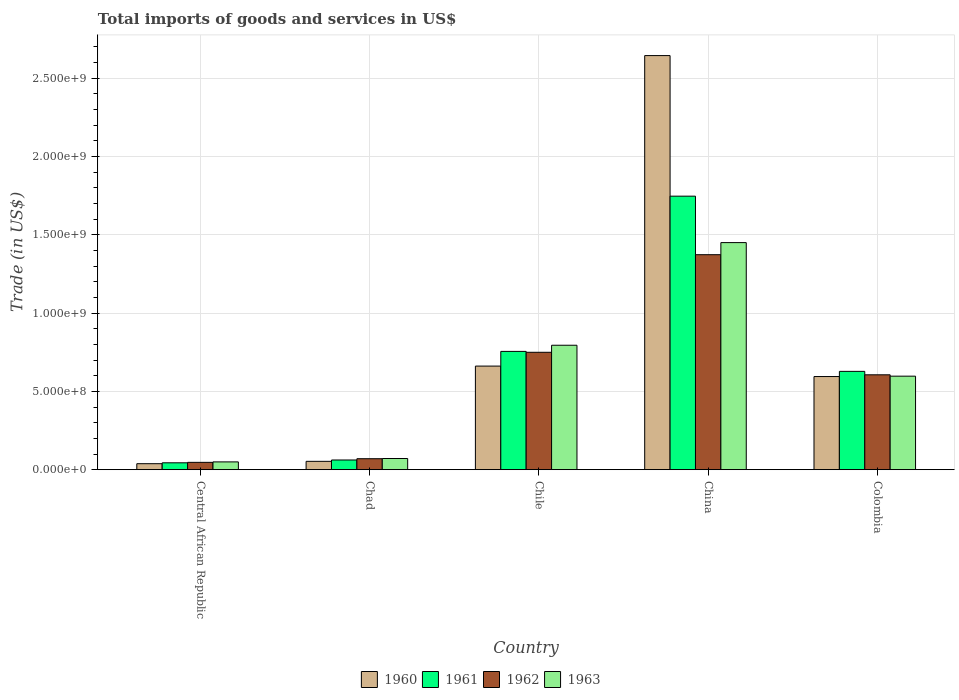How many different coloured bars are there?
Provide a succinct answer. 4. How many bars are there on the 3rd tick from the left?
Keep it short and to the point. 4. What is the label of the 5th group of bars from the left?
Your answer should be very brief. Colombia. What is the total imports of goods and services in 1960 in Central African Republic?
Provide a succinct answer. 3.83e+07. Across all countries, what is the maximum total imports of goods and services in 1963?
Ensure brevity in your answer.  1.45e+09. Across all countries, what is the minimum total imports of goods and services in 1960?
Keep it short and to the point. 3.83e+07. In which country was the total imports of goods and services in 1960 maximum?
Your response must be concise. China. In which country was the total imports of goods and services in 1961 minimum?
Your answer should be very brief. Central African Republic. What is the total total imports of goods and services in 1962 in the graph?
Ensure brevity in your answer.  2.85e+09. What is the difference between the total imports of goods and services in 1963 in China and that in Colombia?
Your response must be concise. 8.53e+08. What is the difference between the total imports of goods and services in 1963 in Chile and the total imports of goods and services in 1960 in Colombia?
Offer a very short reply. 2.00e+08. What is the average total imports of goods and services in 1962 per country?
Your answer should be compact. 5.69e+08. What is the difference between the total imports of goods and services of/in 1961 and total imports of goods and services of/in 1960 in Chad?
Offer a terse response. 8.55e+06. What is the ratio of the total imports of goods and services in 1963 in Central African Republic to that in Colombia?
Provide a succinct answer. 0.08. Is the total imports of goods and services in 1960 in Chile less than that in China?
Your response must be concise. Yes. What is the difference between the highest and the second highest total imports of goods and services in 1962?
Give a very brief answer. -1.44e+08. What is the difference between the highest and the lowest total imports of goods and services in 1960?
Your answer should be very brief. 2.61e+09. In how many countries, is the total imports of goods and services in 1960 greater than the average total imports of goods and services in 1960 taken over all countries?
Provide a short and direct response. 1. Is the sum of the total imports of goods and services in 1963 in Central African Republic and Chile greater than the maximum total imports of goods and services in 1961 across all countries?
Your answer should be very brief. No. What does the 2nd bar from the right in China represents?
Offer a terse response. 1962. How many bars are there?
Give a very brief answer. 20. How many legend labels are there?
Provide a short and direct response. 4. What is the title of the graph?
Make the answer very short. Total imports of goods and services in US$. What is the label or title of the Y-axis?
Offer a very short reply. Trade (in US$). What is the Trade (in US$) of 1960 in Central African Republic?
Offer a terse response. 3.83e+07. What is the Trade (in US$) in 1961 in Central African Republic?
Provide a short and direct response. 4.40e+07. What is the Trade (in US$) in 1962 in Central African Republic?
Your answer should be compact. 4.69e+07. What is the Trade (in US$) in 1963 in Central African Republic?
Your response must be concise. 4.98e+07. What is the Trade (in US$) in 1960 in Chad?
Give a very brief answer. 5.34e+07. What is the Trade (in US$) in 1961 in Chad?
Ensure brevity in your answer.  6.20e+07. What is the Trade (in US$) in 1962 in Chad?
Make the answer very short. 7.02e+07. What is the Trade (in US$) of 1963 in Chad?
Your answer should be compact. 7.14e+07. What is the Trade (in US$) of 1960 in Chile?
Your answer should be compact. 6.62e+08. What is the Trade (in US$) of 1961 in Chile?
Give a very brief answer. 7.55e+08. What is the Trade (in US$) in 1962 in Chile?
Your response must be concise. 7.50e+08. What is the Trade (in US$) of 1963 in Chile?
Your answer should be compact. 7.95e+08. What is the Trade (in US$) in 1960 in China?
Provide a short and direct response. 2.64e+09. What is the Trade (in US$) of 1961 in China?
Offer a very short reply. 1.75e+09. What is the Trade (in US$) in 1962 in China?
Your response must be concise. 1.37e+09. What is the Trade (in US$) of 1963 in China?
Provide a short and direct response. 1.45e+09. What is the Trade (in US$) of 1960 in Colombia?
Offer a terse response. 5.95e+08. What is the Trade (in US$) in 1961 in Colombia?
Provide a short and direct response. 6.28e+08. What is the Trade (in US$) of 1962 in Colombia?
Give a very brief answer. 6.06e+08. What is the Trade (in US$) in 1963 in Colombia?
Keep it short and to the point. 5.97e+08. Across all countries, what is the maximum Trade (in US$) in 1960?
Offer a terse response. 2.64e+09. Across all countries, what is the maximum Trade (in US$) of 1961?
Ensure brevity in your answer.  1.75e+09. Across all countries, what is the maximum Trade (in US$) in 1962?
Offer a terse response. 1.37e+09. Across all countries, what is the maximum Trade (in US$) of 1963?
Provide a succinct answer. 1.45e+09. Across all countries, what is the minimum Trade (in US$) of 1960?
Your answer should be very brief. 3.83e+07. Across all countries, what is the minimum Trade (in US$) in 1961?
Offer a very short reply. 4.40e+07. Across all countries, what is the minimum Trade (in US$) of 1962?
Your answer should be very brief. 4.69e+07. Across all countries, what is the minimum Trade (in US$) in 1963?
Offer a very short reply. 4.98e+07. What is the total Trade (in US$) of 1960 in the graph?
Your answer should be very brief. 3.99e+09. What is the total Trade (in US$) of 1961 in the graph?
Make the answer very short. 3.24e+09. What is the total Trade (in US$) in 1962 in the graph?
Provide a short and direct response. 2.85e+09. What is the total Trade (in US$) in 1963 in the graph?
Your answer should be compact. 2.96e+09. What is the difference between the Trade (in US$) of 1960 in Central African Republic and that in Chad?
Your response must be concise. -1.51e+07. What is the difference between the Trade (in US$) in 1961 in Central African Republic and that in Chad?
Give a very brief answer. -1.79e+07. What is the difference between the Trade (in US$) of 1962 in Central African Republic and that in Chad?
Provide a succinct answer. -2.33e+07. What is the difference between the Trade (in US$) in 1963 in Central African Republic and that in Chad?
Ensure brevity in your answer.  -2.16e+07. What is the difference between the Trade (in US$) in 1960 in Central African Republic and that in Chile?
Offer a very short reply. -6.23e+08. What is the difference between the Trade (in US$) of 1961 in Central African Republic and that in Chile?
Your answer should be compact. -7.11e+08. What is the difference between the Trade (in US$) in 1962 in Central African Republic and that in Chile?
Your answer should be compact. -7.03e+08. What is the difference between the Trade (in US$) of 1963 in Central African Republic and that in Chile?
Make the answer very short. -7.45e+08. What is the difference between the Trade (in US$) in 1960 in Central African Republic and that in China?
Give a very brief answer. -2.61e+09. What is the difference between the Trade (in US$) in 1961 in Central African Republic and that in China?
Offer a very short reply. -1.70e+09. What is the difference between the Trade (in US$) of 1962 in Central African Republic and that in China?
Make the answer very short. -1.33e+09. What is the difference between the Trade (in US$) of 1963 in Central African Republic and that in China?
Ensure brevity in your answer.  -1.40e+09. What is the difference between the Trade (in US$) in 1960 in Central African Republic and that in Colombia?
Offer a very short reply. -5.57e+08. What is the difference between the Trade (in US$) in 1961 in Central African Republic and that in Colombia?
Offer a very short reply. -5.84e+08. What is the difference between the Trade (in US$) of 1962 in Central African Republic and that in Colombia?
Offer a very short reply. -5.59e+08. What is the difference between the Trade (in US$) in 1963 in Central African Republic and that in Colombia?
Make the answer very short. -5.47e+08. What is the difference between the Trade (in US$) in 1960 in Chad and that in Chile?
Give a very brief answer. -6.08e+08. What is the difference between the Trade (in US$) in 1961 in Chad and that in Chile?
Provide a succinct answer. -6.93e+08. What is the difference between the Trade (in US$) of 1962 in Chad and that in Chile?
Provide a succinct answer. -6.80e+08. What is the difference between the Trade (in US$) of 1963 in Chad and that in Chile?
Your answer should be compact. -7.23e+08. What is the difference between the Trade (in US$) in 1960 in Chad and that in China?
Offer a terse response. -2.59e+09. What is the difference between the Trade (in US$) in 1961 in Chad and that in China?
Provide a short and direct response. -1.68e+09. What is the difference between the Trade (in US$) in 1962 in Chad and that in China?
Your response must be concise. -1.30e+09. What is the difference between the Trade (in US$) of 1963 in Chad and that in China?
Offer a very short reply. -1.38e+09. What is the difference between the Trade (in US$) in 1960 in Chad and that in Colombia?
Your response must be concise. -5.41e+08. What is the difference between the Trade (in US$) in 1961 in Chad and that in Colombia?
Make the answer very short. -5.66e+08. What is the difference between the Trade (in US$) in 1962 in Chad and that in Colombia?
Ensure brevity in your answer.  -5.36e+08. What is the difference between the Trade (in US$) in 1963 in Chad and that in Colombia?
Keep it short and to the point. -5.26e+08. What is the difference between the Trade (in US$) of 1960 in Chile and that in China?
Provide a succinct answer. -1.98e+09. What is the difference between the Trade (in US$) of 1961 in Chile and that in China?
Your answer should be very brief. -9.91e+08. What is the difference between the Trade (in US$) of 1962 in Chile and that in China?
Your response must be concise. -6.23e+08. What is the difference between the Trade (in US$) in 1963 in Chile and that in China?
Provide a succinct answer. -6.55e+08. What is the difference between the Trade (in US$) of 1960 in Chile and that in Colombia?
Offer a terse response. 6.68e+07. What is the difference between the Trade (in US$) of 1961 in Chile and that in Colombia?
Offer a very short reply. 1.28e+08. What is the difference between the Trade (in US$) of 1962 in Chile and that in Colombia?
Offer a terse response. 1.44e+08. What is the difference between the Trade (in US$) in 1963 in Chile and that in Colombia?
Your response must be concise. 1.97e+08. What is the difference between the Trade (in US$) in 1960 in China and that in Colombia?
Provide a succinct answer. 2.05e+09. What is the difference between the Trade (in US$) in 1961 in China and that in Colombia?
Provide a short and direct response. 1.12e+09. What is the difference between the Trade (in US$) of 1962 in China and that in Colombia?
Make the answer very short. 7.67e+08. What is the difference between the Trade (in US$) in 1963 in China and that in Colombia?
Ensure brevity in your answer.  8.53e+08. What is the difference between the Trade (in US$) in 1960 in Central African Republic and the Trade (in US$) in 1961 in Chad?
Your answer should be very brief. -2.36e+07. What is the difference between the Trade (in US$) in 1960 in Central African Republic and the Trade (in US$) in 1962 in Chad?
Give a very brief answer. -3.19e+07. What is the difference between the Trade (in US$) in 1960 in Central African Republic and the Trade (in US$) in 1963 in Chad?
Make the answer very short. -3.31e+07. What is the difference between the Trade (in US$) of 1961 in Central African Republic and the Trade (in US$) of 1962 in Chad?
Your response must be concise. -2.62e+07. What is the difference between the Trade (in US$) in 1961 in Central African Republic and the Trade (in US$) in 1963 in Chad?
Provide a short and direct response. -2.74e+07. What is the difference between the Trade (in US$) in 1962 in Central African Republic and the Trade (in US$) in 1963 in Chad?
Your answer should be compact. -2.45e+07. What is the difference between the Trade (in US$) in 1960 in Central African Republic and the Trade (in US$) in 1961 in Chile?
Make the answer very short. -7.17e+08. What is the difference between the Trade (in US$) in 1960 in Central African Republic and the Trade (in US$) in 1962 in Chile?
Give a very brief answer. -7.11e+08. What is the difference between the Trade (in US$) in 1960 in Central African Republic and the Trade (in US$) in 1963 in Chile?
Your answer should be very brief. -7.56e+08. What is the difference between the Trade (in US$) in 1961 in Central African Republic and the Trade (in US$) in 1962 in Chile?
Provide a succinct answer. -7.06e+08. What is the difference between the Trade (in US$) of 1961 in Central African Republic and the Trade (in US$) of 1963 in Chile?
Offer a terse response. -7.51e+08. What is the difference between the Trade (in US$) in 1962 in Central African Republic and the Trade (in US$) in 1963 in Chile?
Your answer should be very brief. -7.48e+08. What is the difference between the Trade (in US$) in 1960 in Central African Republic and the Trade (in US$) in 1961 in China?
Your answer should be compact. -1.71e+09. What is the difference between the Trade (in US$) in 1960 in Central African Republic and the Trade (in US$) in 1962 in China?
Make the answer very short. -1.33e+09. What is the difference between the Trade (in US$) in 1960 in Central African Republic and the Trade (in US$) in 1963 in China?
Ensure brevity in your answer.  -1.41e+09. What is the difference between the Trade (in US$) of 1961 in Central African Republic and the Trade (in US$) of 1962 in China?
Keep it short and to the point. -1.33e+09. What is the difference between the Trade (in US$) in 1961 in Central African Republic and the Trade (in US$) in 1963 in China?
Provide a succinct answer. -1.41e+09. What is the difference between the Trade (in US$) of 1962 in Central African Republic and the Trade (in US$) of 1963 in China?
Offer a terse response. -1.40e+09. What is the difference between the Trade (in US$) in 1960 in Central African Republic and the Trade (in US$) in 1961 in Colombia?
Make the answer very short. -5.90e+08. What is the difference between the Trade (in US$) in 1960 in Central African Republic and the Trade (in US$) in 1962 in Colombia?
Your response must be concise. -5.68e+08. What is the difference between the Trade (in US$) in 1960 in Central African Republic and the Trade (in US$) in 1963 in Colombia?
Offer a terse response. -5.59e+08. What is the difference between the Trade (in US$) in 1961 in Central African Republic and the Trade (in US$) in 1962 in Colombia?
Your answer should be very brief. -5.62e+08. What is the difference between the Trade (in US$) of 1961 in Central African Republic and the Trade (in US$) of 1963 in Colombia?
Provide a succinct answer. -5.53e+08. What is the difference between the Trade (in US$) in 1962 in Central African Republic and the Trade (in US$) in 1963 in Colombia?
Give a very brief answer. -5.50e+08. What is the difference between the Trade (in US$) in 1960 in Chad and the Trade (in US$) in 1961 in Chile?
Keep it short and to the point. -7.02e+08. What is the difference between the Trade (in US$) of 1960 in Chad and the Trade (in US$) of 1962 in Chile?
Make the answer very short. -6.96e+08. What is the difference between the Trade (in US$) in 1960 in Chad and the Trade (in US$) in 1963 in Chile?
Ensure brevity in your answer.  -7.41e+08. What is the difference between the Trade (in US$) in 1961 in Chad and the Trade (in US$) in 1962 in Chile?
Offer a very short reply. -6.88e+08. What is the difference between the Trade (in US$) in 1961 in Chad and the Trade (in US$) in 1963 in Chile?
Your answer should be very brief. -7.33e+08. What is the difference between the Trade (in US$) of 1962 in Chad and the Trade (in US$) of 1963 in Chile?
Provide a short and direct response. -7.25e+08. What is the difference between the Trade (in US$) in 1960 in Chad and the Trade (in US$) in 1961 in China?
Offer a very short reply. -1.69e+09. What is the difference between the Trade (in US$) in 1960 in Chad and the Trade (in US$) in 1962 in China?
Keep it short and to the point. -1.32e+09. What is the difference between the Trade (in US$) in 1960 in Chad and the Trade (in US$) in 1963 in China?
Your answer should be compact. -1.40e+09. What is the difference between the Trade (in US$) of 1961 in Chad and the Trade (in US$) of 1962 in China?
Make the answer very short. -1.31e+09. What is the difference between the Trade (in US$) in 1961 in Chad and the Trade (in US$) in 1963 in China?
Keep it short and to the point. -1.39e+09. What is the difference between the Trade (in US$) of 1962 in Chad and the Trade (in US$) of 1963 in China?
Ensure brevity in your answer.  -1.38e+09. What is the difference between the Trade (in US$) in 1960 in Chad and the Trade (in US$) in 1961 in Colombia?
Provide a succinct answer. -5.75e+08. What is the difference between the Trade (in US$) in 1960 in Chad and the Trade (in US$) in 1962 in Colombia?
Provide a short and direct response. -5.53e+08. What is the difference between the Trade (in US$) of 1960 in Chad and the Trade (in US$) of 1963 in Colombia?
Provide a succinct answer. -5.44e+08. What is the difference between the Trade (in US$) in 1961 in Chad and the Trade (in US$) in 1962 in Colombia?
Provide a succinct answer. -5.44e+08. What is the difference between the Trade (in US$) of 1961 in Chad and the Trade (in US$) of 1963 in Colombia?
Give a very brief answer. -5.35e+08. What is the difference between the Trade (in US$) of 1962 in Chad and the Trade (in US$) of 1963 in Colombia?
Ensure brevity in your answer.  -5.27e+08. What is the difference between the Trade (in US$) of 1960 in Chile and the Trade (in US$) of 1961 in China?
Your answer should be very brief. -1.09e+09. What is the difference between the Trade (in US$) of 1960 in Chile and the Trade (in US$) of 1962 in China?
Offer a very short reply. -7.11e+08. What is the difference between the Trade (in US$) of 1960 in Chile and the Trade (in US$) of 1963 in China?
Provide a succinct answer. -7.88e+08. What is the difference between the Trade (in US$) of 1961 in Chile and the Trade (in US$) of 1962 in China?
Ensure brevity in your answer.  -6.18e+08. What is the difference between the Trade (in US$) of 1961 in Chile and the Trade (in US$) of 1963 in China?
Ensure brevity in your answer.  -6.95e+08. What is the difference between the Trade (in US$) of 1962 in Chile and the Trade (in US$) of 1963 in China?
Ensure brevity in your answer.  -7.00e+08. What is the difference between the Trade (in US$) in 1960 in Chile and the Trade (in US$) in 1961 in Colombia?
Make the answer very short. 3.37e+07. What is the difference between the Trade (in US$) of 1960 in Chile and the Trade (in US$) of 1962 in Colombia?
Your response must be concise. 5.57e+07. What is the difference between the Trade (in US$) in 1960 in Chile and the Trade (in US$) in 1963 in Colombia?
Provide a succinct answer. 6.44e+07. What is the difference between the Trade (in US$) of 1961 in Chile and the Trade (in US$) of 1962 in Colombia?
Your answer should be very brief. 1.50e+08. What is the difference between the Trade (in US$) of 1961 in Chile and the Trade (in US$) of 1963 in Colombia?
Provide a succinct answer. 1.58e+08. What is the difference between the Trade (in US$) in 1962 in Chile and the Trade (in US$) in 1963 in Colombia?
Your response must be concise. 1.52e+08. What is the difference between the Trade (in US$) of 1960 in China and the Trade (in US$) of 1961 in Colombia?
Your answer should be very brief. 2.02e+09. What is the difference between the Trade (in US$) of 1960 in China and the Trade (in US$) of 1962 in Colombia?
Your answer should be compact. 2.04e+09. What is the difference between the Trade (in US$) in 1960 in China and the Trade (in US$) in 1963 in Colombia?
Your answer should be very brief. 2.05e+09. What is the difference between the Trade (in US$) in 1961 in China and the Trade (in US$) in 1962 in Colombia?
Make the answer very short. 1.14e+09. What is the difference between the Trade (in US$) of 1961 in China and the Trade (in US$) of 1963 in Colombia?
Provide a short and direct response. 1.15e+09. What is the difference between the Trade (in US$) of 1962 in China and the Trade (in US$) of 1963 in Colombia?
Offer a very short reply. 7.76e+08. What is the average Trade (in US$) of 1960 per country?
Provide a short and direct response. 7.99e+08. What is the average Trade (in US$) of 1961 per country?
Offer a terse response. 6.47e+08. What is the average Trade (in US$) of 1962 per country?
Ensure brevity in your answer.  5.69e+08. What is the average Trade (in US$) of 1963 per country?
Give a very brief answer. 5.93e+08. What is the difference between the Trade (in US$) in 1960 and Trade (in US$) in 1961 in Central African Republic?
Your answer should be very brief. -5.70e+06. What is the difference between the Trade (in US$) in 1960 and Trade (in US$) in 1962 in Central African Republic?
Your response must be concise. -8.60e+06. What is the difference between the Trade (in US$) of 1960 and Trade (in US$) of 1963 in Central African Republic?
Keep it short and to the point. -1.15e+07. What is the difference between the Trade (in US$) in 1961 and Trade (in US$) in 1962 in Central African Republic?
Offer a very short reply. -2.90e+06. What is the difference between the Trade (in US$) of 1961 and Trade (in US$) of 1963 in Central African Republic?
Make the answer very short. -5.76e+06. What is the difference between the Trade (in US$) in 1962 and Trade (in US$) in 1963 in Central African Republic?
Ensure brevity in your answer.  -2.86e+06. What is the difference between the Trade (in US$) in 1960 and Trade (in US$) in 1961 in Chad?
Provide a short and direct response. -8.55e+06. What is the difference between the Trade (in US$) in 1960 and Trade (in US$) in 1962 in Chad?
Provide a short and direct response. -1.68e+07. What is the difference between the Trade (in US$) in 1960 and Trade (in US$) in 1963 in Chad?
Provide a succinct answer. -1.80e+07. What is the difference between the Trade (in US$) of 1961 and Trade (in US$) of 1962 in Chad?
Provide a succinct answer. -8.23e+06. What is the difference between the Trade (in US$) in 1961 and Trade (in US$) in 1963 in Chad?
Your answer should be compact. -9.45e+06. What is the difference between the Trade (in US$) of 1962 and Trade (in US$) of 1963 in Chad?
Ensure brevity in your answer.  -1.22e+06. What is the difference between the Trade (in US$) of 1960 and Trade (in US$) of 1961 in Chile?
Offer a very short reply. -9.38e+07. What is the difference between the Trade (in US$) of 1960 and Trade (in US$) of 1962 in Chile?
Keep it short and to the point. -8.81e+07. What is the difference between the Trade (in US$) of 1960 and Trade (in US$) of 1963 in Chile?
Keep it short and to the point. -1.33e+08. What is the difference between the Trade (in US$) of 1961 and Trade (in US$) of 1962 in Chile?
Keep it short and to the point. 5.71e+06. What is the difference between the Trade (in US$) in 1961 and Trade (in US$) in 1963 in Chile?
Keep it short and to the point. -3.92e+07. What is the difference between the Trade (in US$) of 1962 and Trade (in US$) of 1963 in Chile?
Give a very brief answer. -4.50e+07. What is the difference between the Trade (in US$) of 1960 and Trade (in US$) of 1961 in China?
Give a very brief answer. 8.98e+08. What is the difference between the Trade (in US$) of 1960 and Trade (in US$) of 1962 in China?
Offer a very short reply. 1.27e+09. What is the difference between the Trade (in US$) in 1960 and Trade (in US$) in 1963 in China?
Provide a short and direct response. 1.19e+09. What is the difference between the Trade (in US$) of 1961 and Trade (in US$) of 1962 in China?
Provide a succinct answer. 3.74e+08. What is the difference between the Trade (in US$) of 1961 and Trade (in US$) of 1963 in China?
Your response must be concise. 2.97e+08. What is the difference between the Trade (in US$) in 1962 and Trade (in US$) in 1963 in China?
Provide a short and direct response. -7.72e+07. What is the difference between the Trade (in US$) of 1960 and Trade (in US$) of 1961 in Colombia?
Give a very brief answer. -3.30e+07. What is the difference between the Trade (in US$) in 1960 and Trade (in US$) in 1962 in Colombia?
Your answer should be very brief. -1.10e+07. What is the difference between the Trade (in US$) in 1960 and Trade (in US$) in 1963 in Colombia?
Your answer should be very brief. -2.39e+06. What is the difference between the Trade (in US$) in 1961 and Trade (in US$) in 1962 in Colombia?
Keep it short and to the point. 2.20e+07. What is the difference between the Trade (in US$) in 1961 and Trade (in US$) in 1963 in Colombia?
Provide a short and direct response. 3.06e+07. What is the difference between the Trade (in US$) in 1962 and Trade (in US$) in 1963 in Colombia?
Your answer should be very brief. 8.64e+06. What is the ratio of the Trade (in US$) of 1960 in Central African Republic to that in Chad?
Keep it short and to the point. 0.72. What is the ratio of the Trade (in US$) in 1961 in Central African Republic to that in Chad?
Provide a short and direct response. 0.71. What is the ratio of the Trade (in US$) in 1962 in Central African Republic to that in Chad?
Your answer should be compact. 0.67. What is the ratio of the Trade (in US$) in 1963 in Central African Republic to that in Chad?
Your answer should be compact. 0.7. What is the ratio of the Trade (in US$) in 1960 in Central African Republic to that in Chile?
Offer a terse response. 0.06. What is the ratio of the Trade (in US$) in 1961 in Central African Republic to that in Chile?
Your answer should be very brief. 0.06. What is the ratio of the Trade (in US$) in 1962 in Central African Republic to that in Chile?
Make the answer very short. 0.06. What is the ratio of the Trade (in US$) of 1963 in Central African Republic to that in Chile?
Offer a terse response. 0.06. What is the ratio of the Trade (in US$) of 1960 in Central African Republic to that in China?
Your answer should be very brief. 0.01. What is the ratio of the Trade (in US$) in 1961 in Central African Republic to that in China?
Keep it short and to the point. 0.03. What is the ratio of the Trade (in US$) in 1962 in Central African Republic to that in China?
Keep it short and to the point. 0.03. What is the ratio of the Trade (in US$) in 1963 in Central African Republic to that in China?
Make the answer very short. 0.03. What is the ratio of the Trade (in US$) of 1960 in Central African Republic to that in Colombia?
Your answer should be compact. 0.06. What is the ratio of the Trade (in US$) in 1961 in Central African Republic to that in Colombia?
Provide a succinct answer. 0.07. What is the ratio of the Trade (in US$) in 1962 in Central African Republic to that in Colombia?
Your answer should be compact. 0.08. What is the ratio of the Trade (in US$) in 1963 in Central African Republic to that in Colombia?
Keep it short and to the point. 0.08. What is the ratio of the Trade (in US$) in 1960 in Chad to that in Chile?
Keep it short and to the point. 0.08. What is the ratio of the Trade (in US$) of 1961 in Chad to that in Chile?
Your response must be concise. 0.08. What is the ratio of the Trade (in US$) of 1962 in Chad to that in Chile?
Your response must be concise. 0.09. What is the ratio of the Trade (in US$) of 1963 in Chad to that in Chile?
Your answer should be very brief. 0.09. What is the ratio of the Trade (in US$) in 1960 in Chad to that in China?
Offer a terse response. 0.02. What is the ratio of the Trade (in US$) of 1961 in Chad to that in China?
Give a very brief answer. 0.04. What is the ratio of the Trade (in US$) of 1962 in Chad to that in China?
Keep it short and to the point. 0.05. What is the ratio of the Trade (in US$) in 1963 in Chad to that in China?
Keep it short and to the point. 0.05. What is the ratio of the Trade (in US$) in 1960 in Chad to that in Colombia?
Ensure brevity in your answer.  0.09. What is the ratio of the Trade (in US$) in 1961 in Chad to that in Colombia?
Keep it short and to the point. 0.1. What is the ratio of the Trade (in US$) in 1962 in Chad to that in Colombia?
Provide a succinct answer. 0.12. What is the ratio of the Trade (in US$) in 1963 in Chad to that in Colombia?
Offer a very short reply. 0.12. What is the ratio of the Trade (in US$) in 1960 in Chile to that in China?
Provide a short and direct response. 0.25. What is the ratio of the Trade (in US$) in 1961 in Chile to that in China?
Your answer should be compact. 0.43. What is the ratio of the Trade (in US$) in 1962 in Chile to that in China?
Keep it short and to the point. 0.55. What is the ratio of the Trade (in US$) of 1963 in Chile to that in China?
Give a very brief answer. 0.55. What is the ratio of the Trade (in US$) of 1960 in Chile to that in Colombia?
Your answer should be very brief. 1.11. What is the ratio of the Trade (in US$) of 1961 in Chile to that in Colombia?
Keep it short and to the point. 1.2. What is the ratio of the Trade (in US$) of 1962 in Chile to that in Colombia?
Give a very brief answer. 1.24. What is the ratio of the Trade (in US$) of 1963 in Chile to that in Colombia?
Provide a succinct answer. 1.33. What is the ratio of the Trade (in US$) in 1960 in China to that in Colombia?
Your response must be concise. 4.45. What is the ratio of the Trade (in US$) in 1961 in China to that in Colombia?
Your answer should be compact. 2.78. What is the ratio of the Trade (in US$) in 1962 in China to that in Colombia?
Provide a succinct answer. 2.27. What is the ratio of the Trade (in US$) of 1963 in China to that in Colombia?
Ensure brevity in your answer.  2.43. What is the difference between the highest and the second highest Trade (in US$) in 1960?
Give a very brief answer. 1.98e+09. What is the difference between the highest and the second highest Trade (in US$) of 1961?
Offer a very short reply. 9.91e+08. What is the difference between the highest and the second highest Trade (in US$) of 1962?
Make the answer very short. 6.23e+08. What is the difference between the highest and the second highest Trade (in US$) in 1963?
Provide a short and direct response. 6.55e+08. What is the difference between the highest and the lowest Trade (in US$) of 1960?
Provide a succinct answer. 2.61e+09. What is the difference between the highest and the lowest Trade (in US$) of 1961?
Your answer should be compact. 1.70e+09. What is the difference between the highest and the lowest Trade (in US$) of 1962?
Give a very brief answer. 1.33e+09. What is the difference between the highest and the lowest Trade (in US$) of 1963?
Keep it short and to the point. 1.40e+09. 